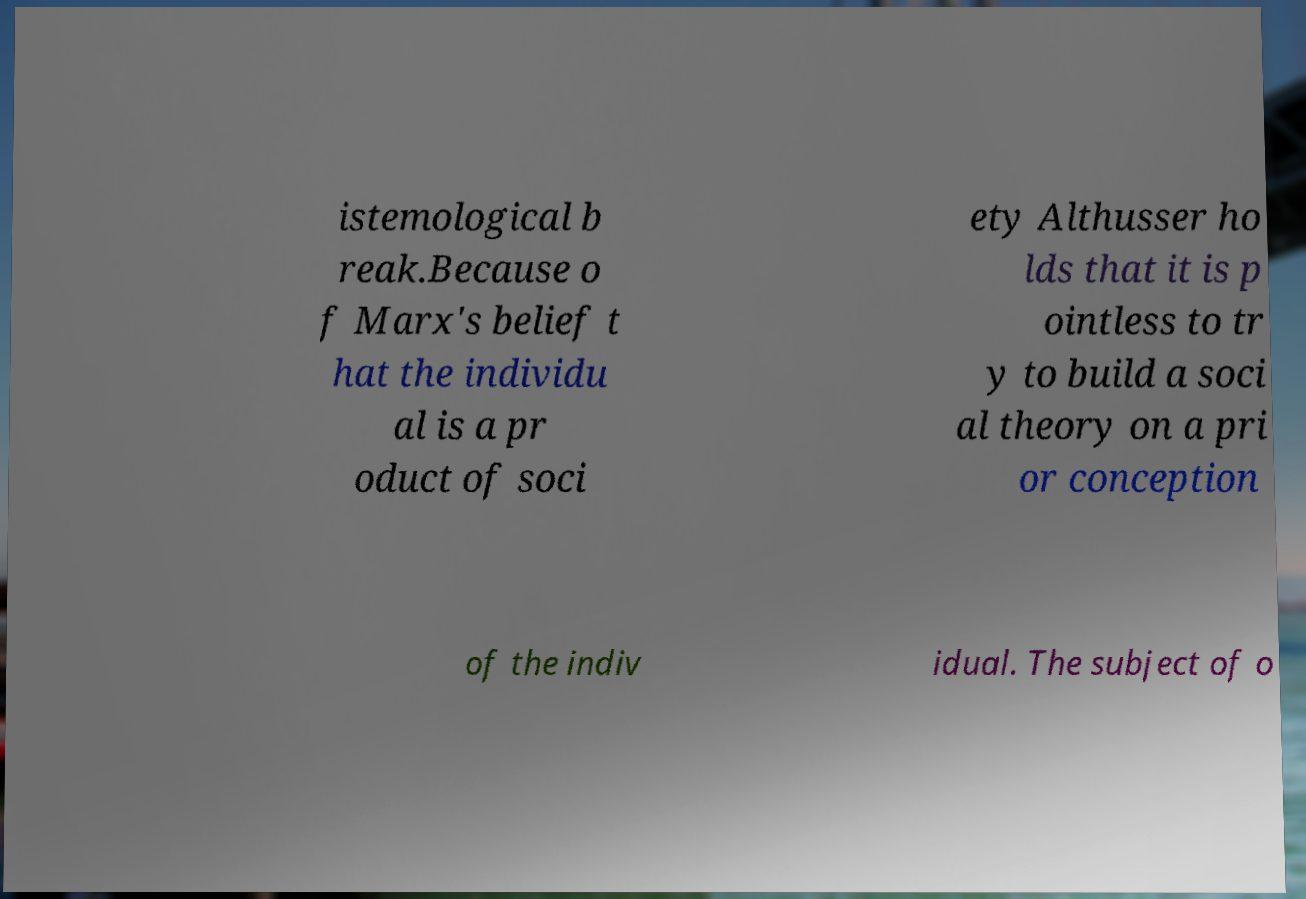Can you accurately transcribe the text from the provided image for me? istemological b reak.Because o f Marx's belief t hat the individu al is a pr oduct of soci ety Althusser ho lds that it is p ointless to tr y to build a soci al theory on a pri or conception of the indiv idual. The subject of o 